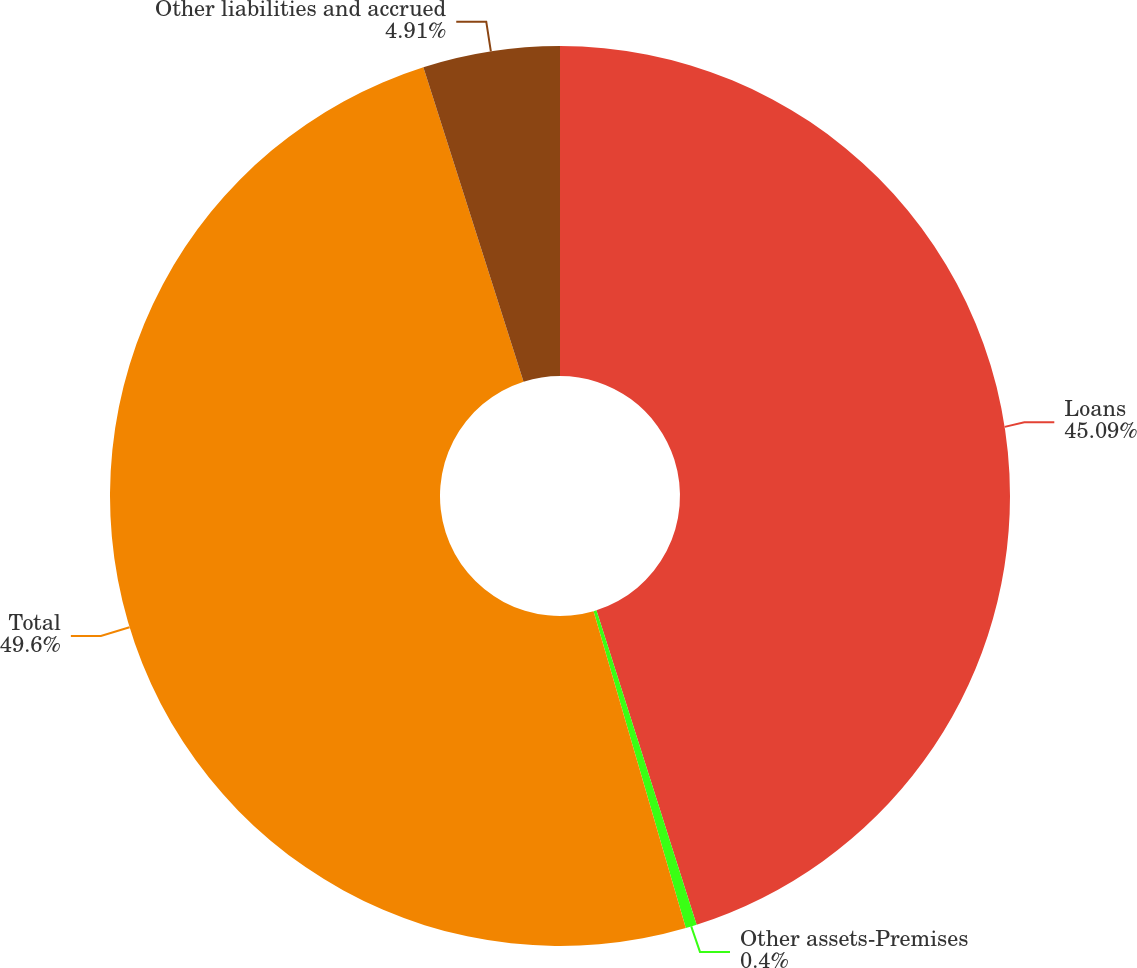<chart> <loc_0><loc_0><loc_500><loc_500><pie_chart><fcel>Loans<fcel>Other assets-Premises<fcel>Total<fcel>Other liabilities and accrued<nl><fcel>45.09%<fcel>0.4%<fcel>49.6%<fcel>4.91%<nl></chart> 